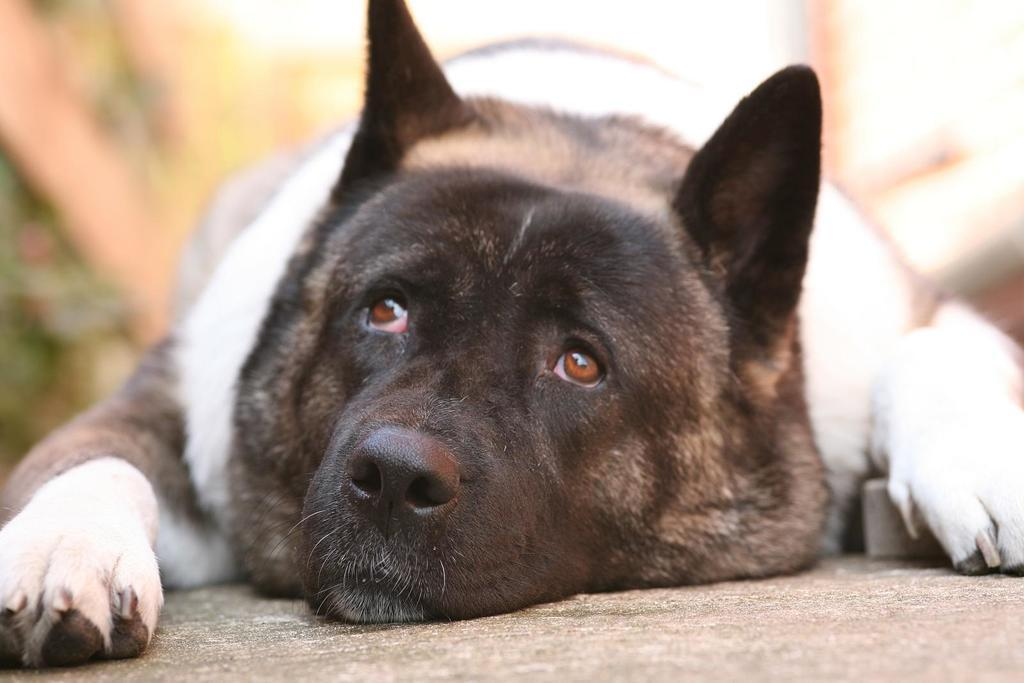What type of animal is in the image? There is a dog in the image. What color combination does the dog have? The dog has a black and white color combination. What position is the dog in? The dog is lying on the floor. Can you describe the background of the image? The background of the image is blurred. What type of peace symbol can be seen in the image? There is no peace symbol present in the image; it features a dog lying on the floor. What kind of toy is the dog playing with in the image? There is no toy visible in the image; the dog is simply lying on the floor. 